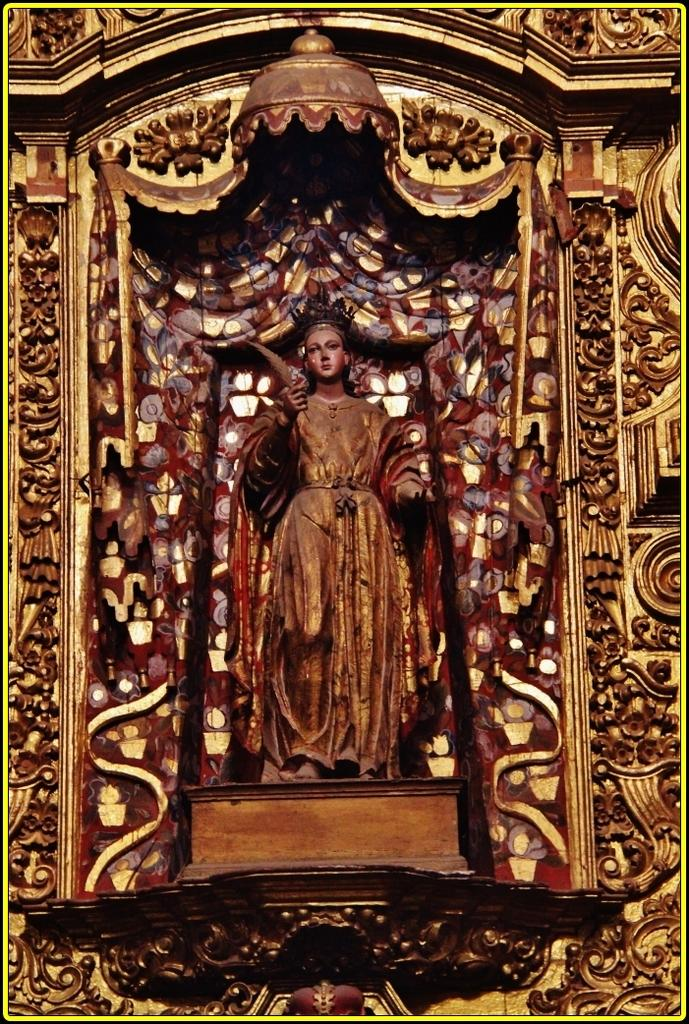What is the main subject of the image? There is a sculpture in the image. How many cents are visible on the shelf in the image? There is no mention of cents or a shelf in the image; it only features a sculpture. 